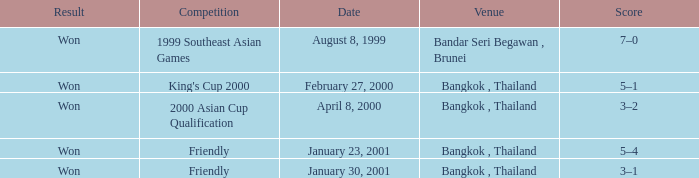Help me parse the entirety of this table. {'header': ['Result', 'Competition', 'Date', 'Venue', 'Score'], 'rows': [['Won', '1999 Southeast Asian Games', 'August 8, 1999', 'Bandar Seri Begawan , Brunei', '7–0'], ['Won', "King's Cup 2000", 'February 27, 2000', 'Bangkok , Thailand', '5–1'], ['Won', '2000 Asian Cup Qualification', 'April 8, 2000', 'Bangkok , Thailand', '3–2'], ['Won', 'Friendly', 'January 23, 2001', 'Bangkok , Thailand', '5–4'], ['Won', 'Friendly', 'January 30, 2001', 'Bangkok , Thailand', '3–1']]} What was the result of the game that was played on february 27, 2000? Won. 